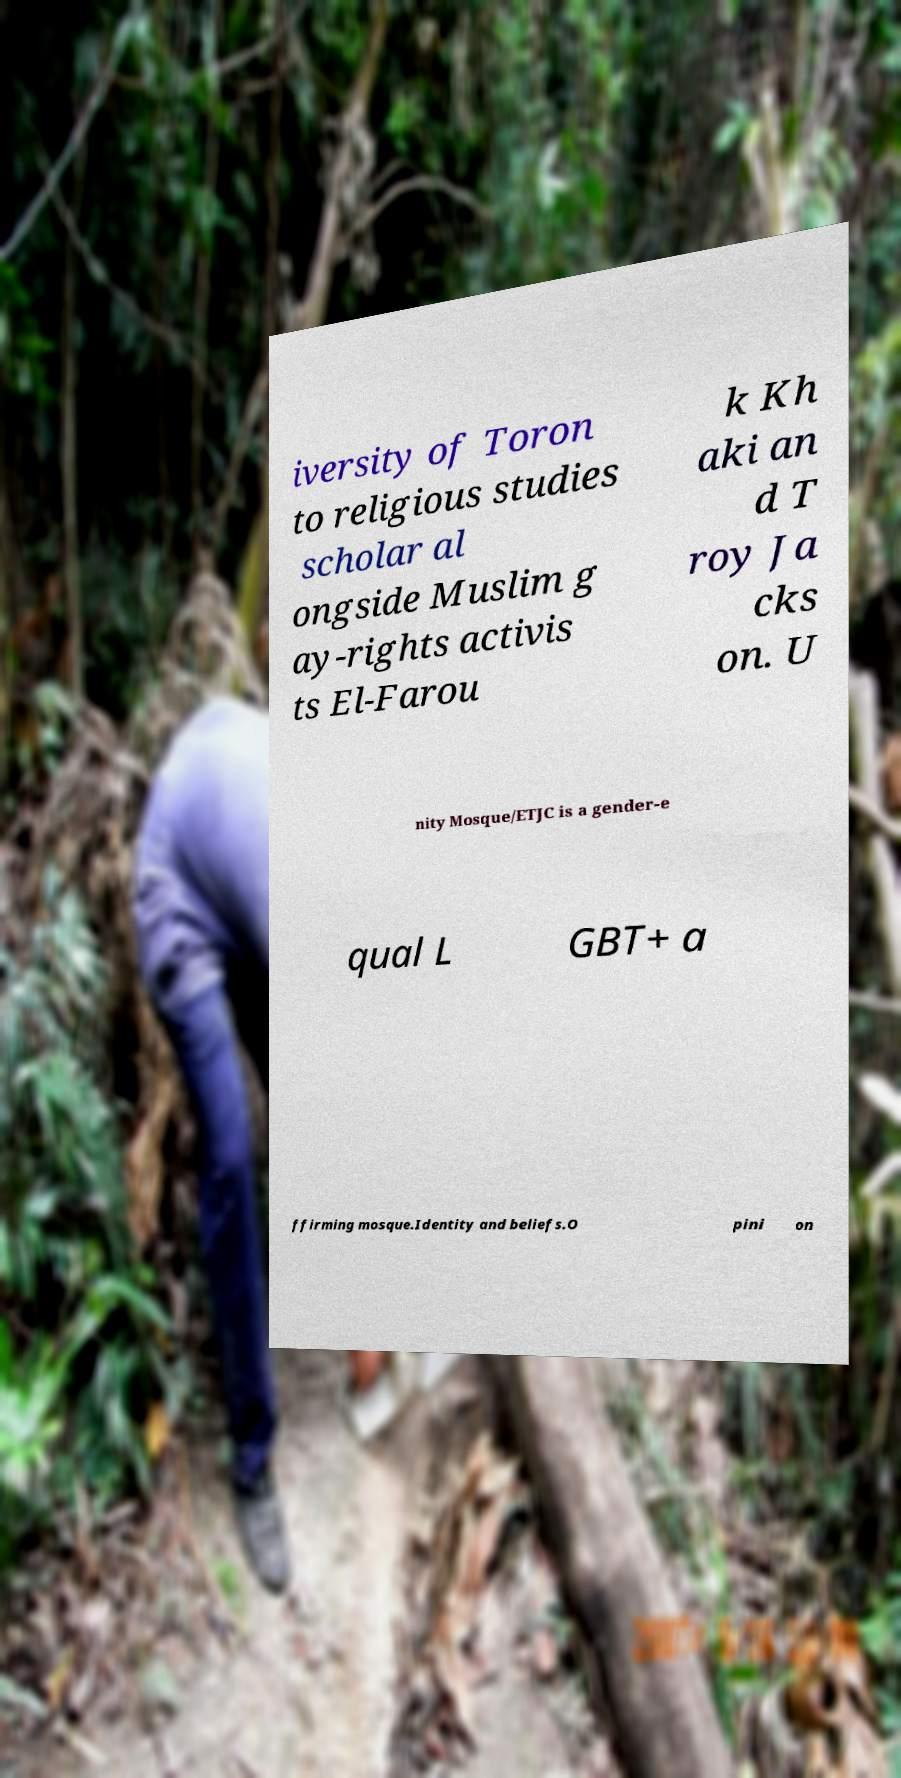What messages or text are displayed in this image? I need them in a readable, typed format. iversity of Toron to religious studies scholar al ongside Muslim g ay-rights activis ts El-Farou k Kh aki an d T roy Ja cks on. U nity Mosque/ETJC is a gender-e qual L GBT+ a ffirming mosque.Identity and beliefs.O pini on 